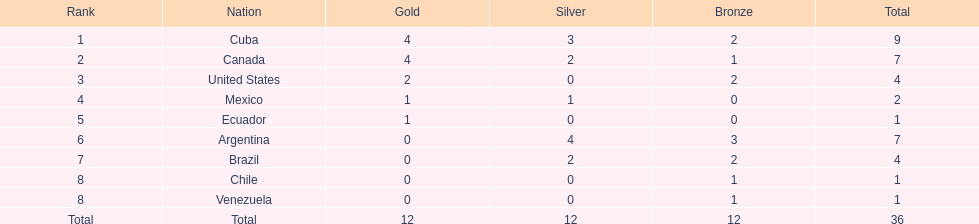How many total medals did argentina win? 7. I'm looking to parse the entire table for insights. Could you assist me with that? {'header': ['Rank', 'Nation', 'Gold', 'Silver', 'Bronze', 'Total'], 'rows': [['1', 'Cuba', '4', '3', '2', '9'], ['2', 'Canada', '4', '2', '1', '7'], ['3', 'United States', '2', '0', '2', '4'], ['4', 'Mexico', '1', '1', '0', '2'], ['5', 'Ecuador', '1', '0', '0', '1'], ['6', 'Argentina', '0', '4', '3', '7'], ['7', 'Brazil', '0', '2', '2', '4'], ['8', 'Chile', '0', '0', '1', '1'], ['8', 'Venezuela', '0', '0', '1', '1'], ['Total', 'Total', '12', '12', '12', '36']]} 